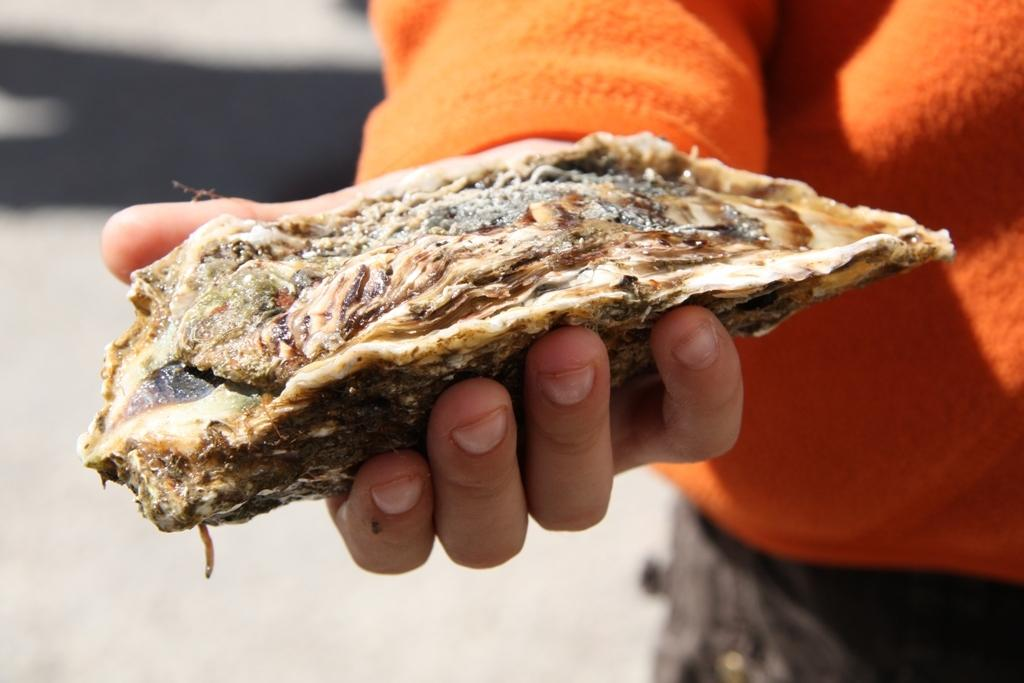What is the main subject of the image? There is a person standing in the image. What is the person holding in their hands? The person is holding an object in their hands, which appears to be a food item. Can you describe the background of the image? The background of the image is blurred. What type of thrill can be seen in the person's eyes in the image? There is no indication of a thrill or any specific emotion in the person's eyes in the image. 